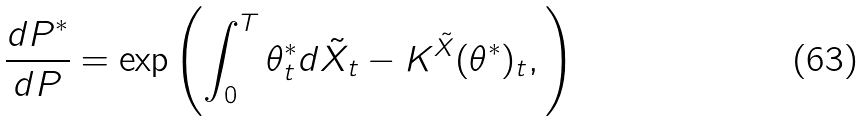Convert formula to latex. <formula><loc_0><loc_0><loc_500><loc_500>\frac { d P ^ { * } } { d P } = \exp \left ( \int _ { 0 } ^ { T } \theta ^ { * } _ { t } d \tilde { X } _ { t } - K ^ { \tilde { X } } ( \theta ^ { * } ) _ { t } , \right )</formula> 